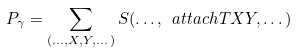Convert formula to latex. <formula><loc_0><loc_0><loc_500><loc_500>P _ { \gamma } = \sum _ { ( \dots , X , Y , \dots ) } S ( \dots , \ a t t a c h { T } { X } { Y } , \dots )</formula> 